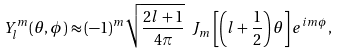Convert formula to latex. <formula><loc_0><loc_0><loc_500><loc_500>Y _ { l } ^ { m } ( \theta , \phi ) \approx ( - 1 ) ^ { m } \sqrt { \frac { 2 l + 1 } { 4 \pi } } \ J _ { m } \left [ \left ( l + \frac { 1 } { 2 } \right ) \theta \right ] e ^ { i m \phi } ,</formula> 